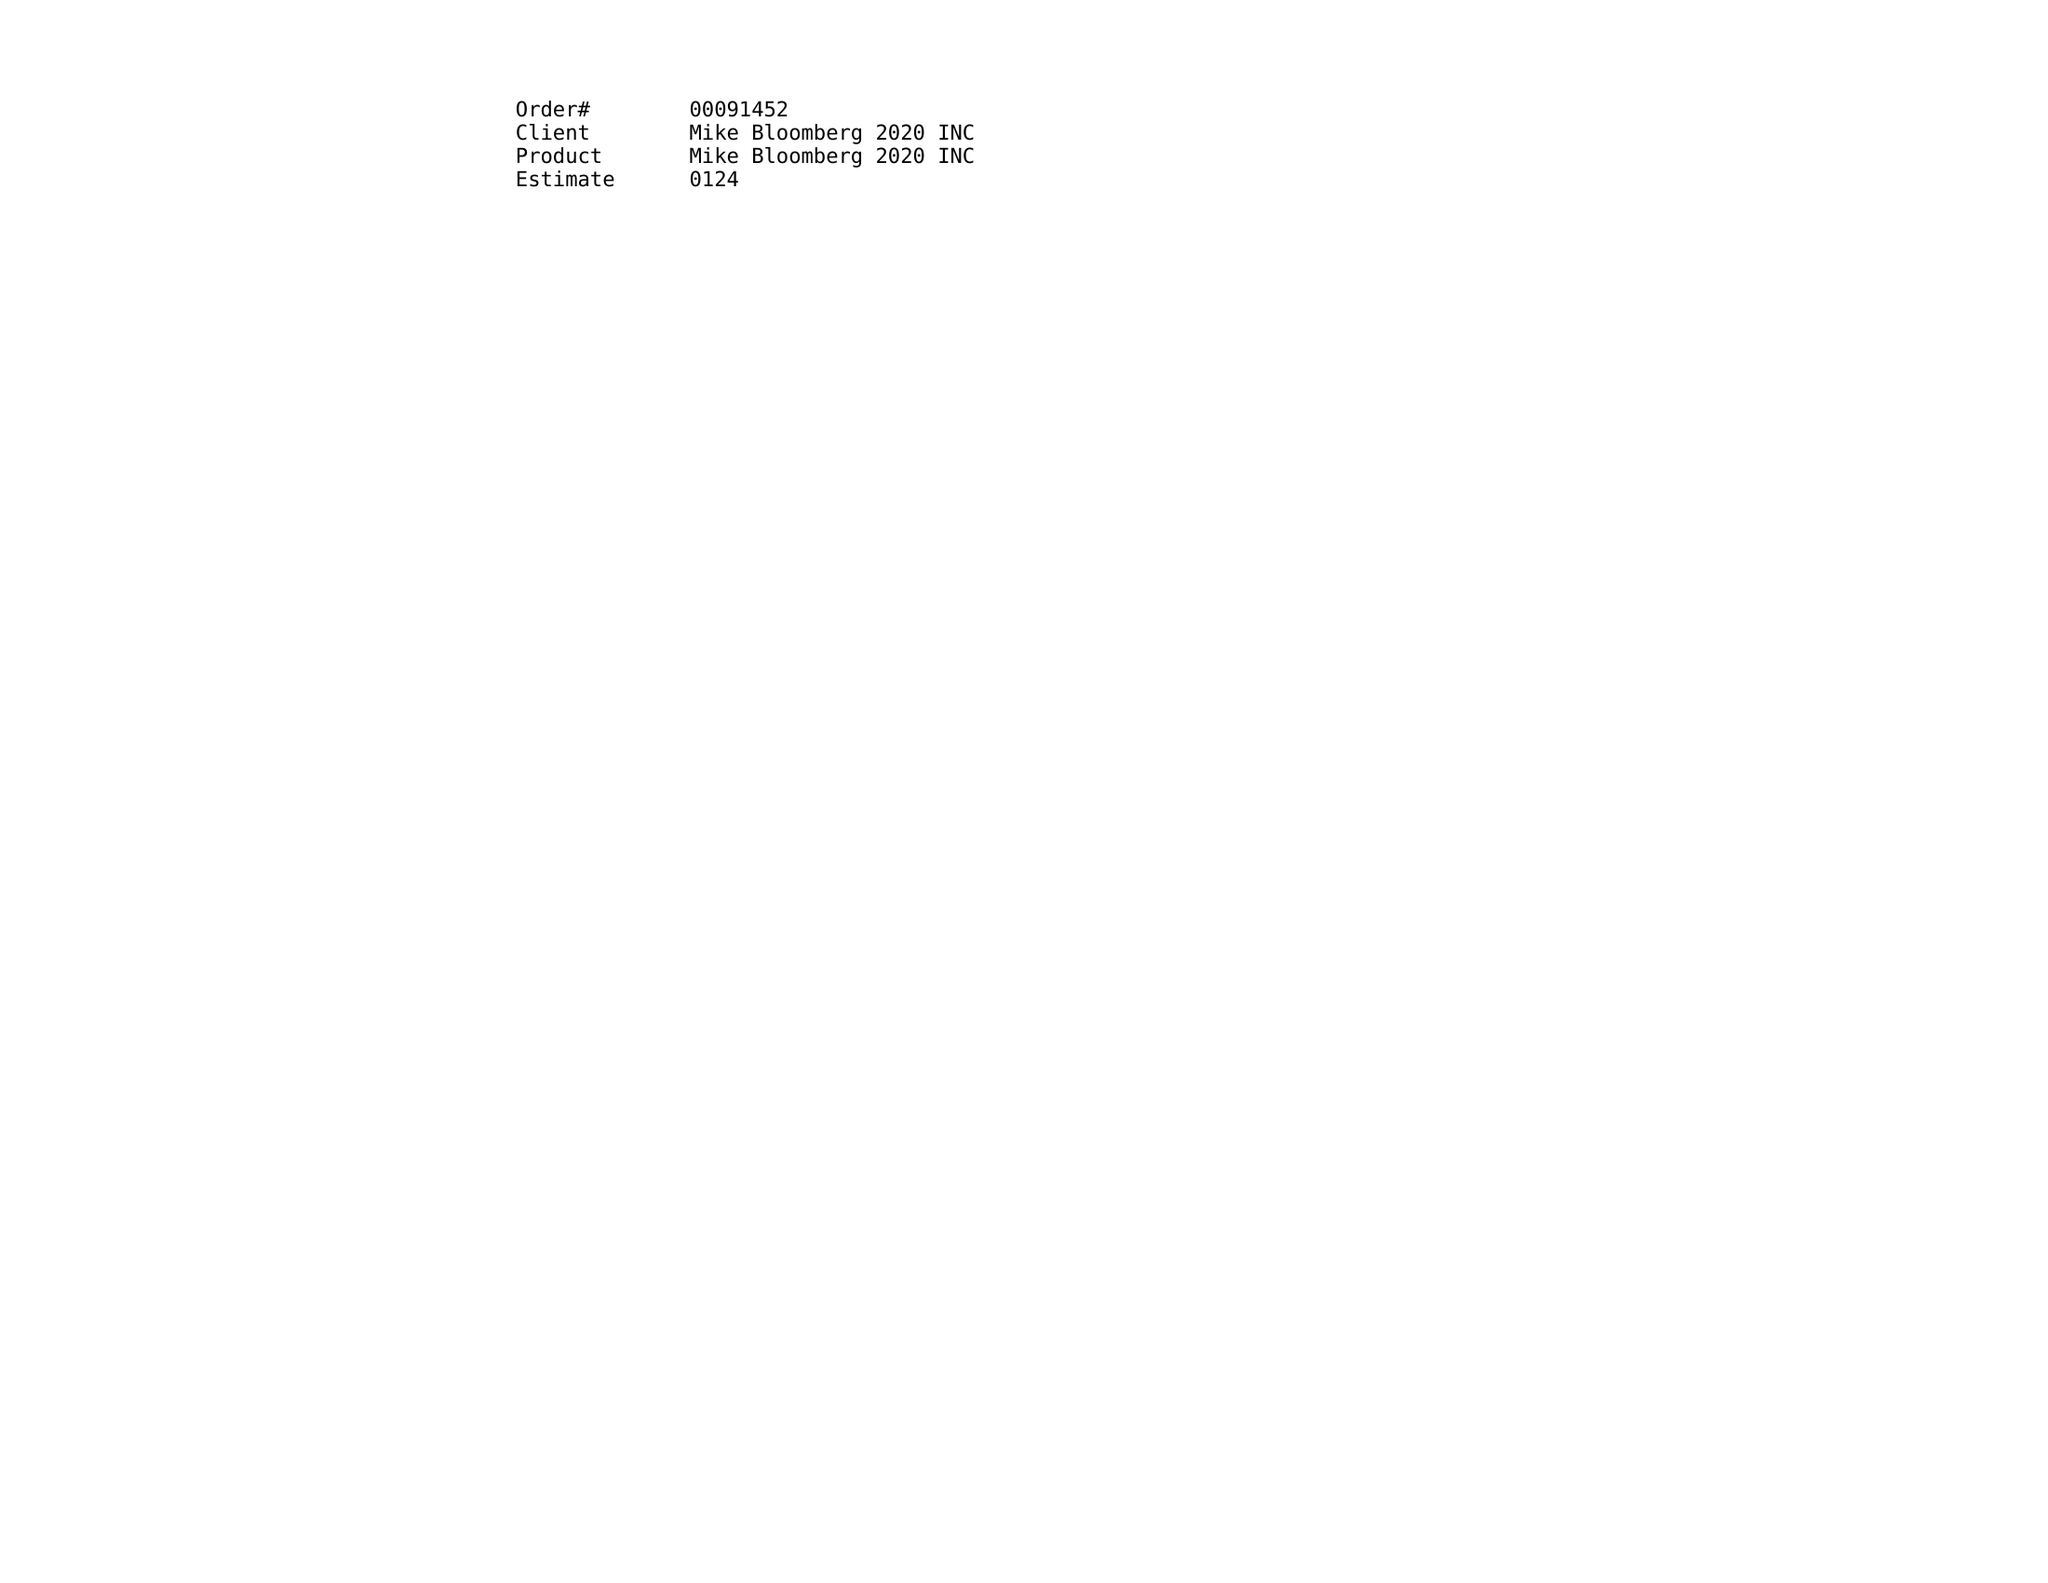What is the value for the advertiser?
Answer the question using a single word or phrase. MBLM MIKE BLOOMBERG 2020 INC 